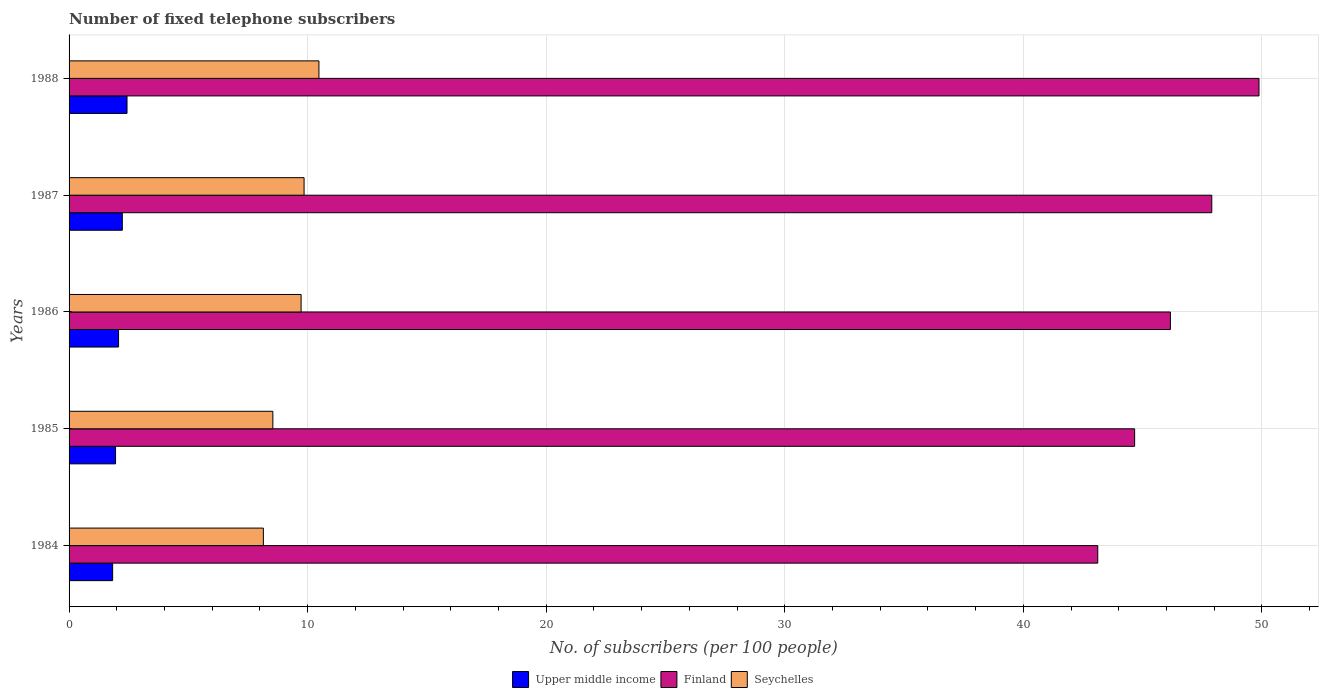Are the number of bars per tick equal to the number of legend labels?
Offer a very short reply. Yes. How many bars are there on the 2nd tick from the top?
Give a very brief answer. 3. In how many cases, is the number of bars for a given year not equal to the number of legend labels?
Provide a short and direct response. 0. What is the number of fixed telephone subscribers in Finland in 1987?
Offer a very short reply. 47.9. Across all years, what is the maximum number of fixed telephone subscribers in Finland?
Offer a terse response. 49.88. Across all years, what is the minimum number of fixed telephone subscribers in Seychelles?
Make the answer very short. 8.14. In which year was the number of fixed telephone subscribers in Upper middle income maximum?
Ensure brevity in your answer.  1988. In which year was the number of fixed telephone subscribers in Finland minimum?
Your response must be concise. 1984. What is the total number of fixed telephone subscribers in Upper middle income in the graph?
Make the answer very short. 10.51. What is the difference between the number of fixed telephone subscribers in Finland in 1985 and that in 1988?
Offer a very short reply. -5.21. What is the difference between the number of fixed telephone subscribers in Upper middle income in 1988 and the number of fixed telephone subscribers in Seychelles in 1986?
Offer a terse response. -7.3. What is the average number of fixed telephone subscribers in Upper middle income per year?
Offer a very short reply. 2.1. In the year 1988, what is the difference between the number of fixed telephone subscribers in Seychelles and number of fixed telephone subscribers in Upper middle income?
Ensure brevity in your answer.  8.05. What is the ratio of the number of fixed telephone subscribers in Upper middle income in 1986 to that in 1987?
Offer a terse response. 0.93. What is the difference between the highest and the second highest number of fixed telephone subscribers in Seychelles?
Provide a succinct answer. 0.62. What is the difference between the highest and the lowest number of fixed telephone subscribers in Seychelles?
Your answer should be very brief. 2.33. In how many years, is the number of fixed telephone subscribers in Seychelles greater than the average number of fixed telephone subscribers in Seychelles taken over all years?
Your answer should be very brief. 3. What does the 2nd bar from the top in 1984 represents?
Offer a terse response. Finland. What does the 2nd bar from the bottom in 1988 represents?
Provide a succinct answer. Finland. Is it the case that in every year, the sum of the number of fixed telephone subscribers in Seychelles and number of fixed telephone subscribers in Finland is greater than the number of fixed telephone subscribers in Upper middle income?
Provide a succinct answer. Yes. How many bars are there?
Ensure brevity in your answer.  15. Are all the bars in the graph horizontal?
Offer a terse response. Yes. How many years are there in the graph?
Your response must be concise. 5. Are the values on the major ticks of X-axis written in scientific E-notation?
Provide a short and direct response. No. Does the graph contain any zero values?
Offer a very short reply. No. Does the graph contain grids?
Your response must be concise. Yes. How many legend labels are there?
Ensure brevity in your answer.  3. How are the legend labels stacked?
Offer a terse response. Horizontal. What is the title of the graph?
Provide a short and direct response. Number of fixed telephone subscribers. Does "Latin America(developing only)" appear as one of the legend labels in the graph?
Provide a succinct answer. No. What is the label or title of the X-axis?
Make the answer very short. No. of subscribers (per 100 people). What is the label or title of the Y-axis?
Your answer should be very brief. Years. What is the No. of subscribers (per 100 people) in Upper middle income in 1984?
Ensure brevity in your answer.  1.83. What is the No. of subscribers (per 100 people) of Finland in 1984?
Offer a terse response. 43.12. What is the No. of subscribers (per 100 people) of Seychelles in 1984?
Give a very brief answer. 8.14. What is the No. of subscribers (per 100 people) in Upper middle income in 1985?
Keep it short and to the point. 1.95. What is the No. of subscribers (per 100 people) in Finland in 1985?
Provide a short and direct response. 44.67. What is the No. of subscribers (per 100 people) of Seychelles in 1985?
Give a very brief answer. 8.54. What is the No. of subscribers (per 100 people) of Upper middle income in 1986?
Your answer should be compact. 2.07. What is the No. of subscribers (per 100 people) in Finland in 1986?
Your answer should be compact. 46.17. What is the No. of subscribers (per 100 people) of Seychelles in 1986?
Provide a succinct answer. 9.73. What is the No. of subscribers (per 100 people) in Upper middle income in 1987?
Provide a short and direct response. 2.23. What is the No. of subscribers (per 100 people) of Finland in 1987?
Offer a terse response. 47.9. What is the No. of subscribers (per 100 people) of Seychelles in 1987?
Ensure brevity in your answer.  9.85. What is the No. of subscribers (per 100 people) in Upper middle income in 1988?
Your response must be concise. 2.43. What is the No. of subscribers (per 100 people) in Finland in 1988?
Offer a terse response. 49.88. What is the No. of subscribers (per 100 people) in Seychelles in 1988?
Make the answer very short. 10.47. Across all years, what is the maximum No. of subscribers (per 100 people) in Upper middle income?
Your answer should be very brief. 2.43. Across all years, what is the maximum No. of subscribers (per 100 people) in Finland?
Offer a terse response. 49.88. Across all years, what is the maximum No. of subscribers (per 100 people) of Seychelles?
Your answer should be very brief. 10.47. Across all years, what is the minimum No. of subscribers (per 100 people) of Upper middle income?
Your answer should be compact. 1.83. Across all years, what is the minimum No. of subscribers (per 100 people) in Finland?
Offer a terse response. 43.12. Across all years, what is the minimum No. of subscribers (per 100 people) in Seychelles?
Your response must be concise. 8.14. What is the total No. of subscribers (per 100 people) of Upper middle income in the graph?
Offer a terse response. 10.51. What is the total No. of subscribers (per 100 people) in Finland in the graph?
Provide a succinct answer. 231.74. What is the total No. of subscribers (per 100 people) in Seychelles in the graph?
Offer a very short reply. 46.74. What is the difference between the No. of subscribers (per 100 people) of Upper middle income in 1984 and that in 1985?
Give a very brief answer. -0.12. What is the difference between the No. of subscribers (per 100 people) in Finland in 1984 and that in 1985?
Provide a short and direct response. -1.55. What is the difference between the No. of subscribers (per 100 people) of Seychelles in 1984 and that in 1985?
Offer a very short reply. -0.4. What is the difference between the No. of subscribers (per 100 people) of Upper middle income in 1984 and that in 1986?
Ensure brevity in your answer.  -0.25. What is the difference between the No. of subscribers (per 100 people) in Finland in 1984 and that in 1986?
Make the answer very short. -3.05. What is the difference between the No. of subscribers (per 100 people) in Seychelles in 1984 and that in 1986?
Offer a very short reply. -1.58. What is the difference between the No. of subscribers (per 100 people) in Upper middle income in 1984 and that in 1987?
Your response must be concise. -0.41. What is the difference between the No. of subscribers (per 100 people) of Finland in 1984 and that in 1987?
Your answer should be compact. -4.78. What is the difference between the No. of subscribers (per 100 people) in Seychelles in 1984 and that in 1987?
Provide a succinct answer. -1.71. What is the difference between the No. of subscribers (per 100 people) in Upper middle income in 1984 and that in 1988?
Provide a short and direct response. -0.6. What is the difference between the No. of subscribers (per 100 people) in Finland in 1984 and that in 1988?
Your response must be concise. -6.76. What is the difference between the No. of subscribers (per 100 people) of Seychelles in 1984 and that in 1988?
Provide a short and direct response. -2.33. What is the difference between the No. of subscribers (per 100 people) of Upper middle income in 1985 and that in 1986?
Your answer should be compact. -0.13. What is the difference between the No. of subscribers (per 100 people) in Finland in 1985 and that in 1986?
Your response must be concise. -1.5. What is the difference between the No. of subscribers (per 100 people) of Seychelles in 1985 and that in 1986?
Keep it short and to the point. -1.18. What is the difference between the No. of subscribers (per 100 people) in Upper middle income in 1985 and that in 1987?
Your answer should be compact. -0.28. What is the difference between the No. of subscribers (per 100 people) in Finland in 1985 and that in 1987?
Ensure brevity in your answer.  -3.23. What is the difference between the No. of subscribers (per 100 people) in Seychelles in 1985 and that in 1987?
Offer a very short reply. -1.31. What is the difference between the No. of subscribers (per 100 people) in Upper middle income in 1985 and that in 1988?
Give a very brief answer. -0.48. What is the difference between the No. of subscribers (per 100 people) of Finland in 1985 and that in 1988?
Your response must be concise. -5.21. What is the difference between the No. of subscribers (per 100 people) in Seychelles in 1985 and that in 1988?
Make the answer very short. -1.93. What is the difference between the No. of subscribers (per 100 people) of Upper middle income in 1986 and that in 1987?
Make the answer very short. -0.16. What is the difference between the No. of subscribers (per 100 people) of Finland in 1986 and that in 1987?
Your response must be concise. -1.73. What is the difference between the No. of subscribers (per 100 people) in Seychelles in 1986 and that in 1987?
Ensure brevity in your answer.  -0.12. What is the difference between the No. of subscribers (per 100 people) of Upper middle income in 1986 and that in 1988?
Provide a succinct answer. -0.35. What is the difference between the No. of subscribers (per 100 people) of Finland in 1986 and that in 1988?
Keep it short and to the point. -3.71. What is the difference between the No. of subscribers (per 100 people) of Seychelles in 1986 and that in 1988?
Provide a short and direct response. -0.75. What is the difference between the No. of subscribers (per 100 people) of Upper middle income in 1987 and that in 1988?
Make the answer very short. -0.2. What is the difference between the No. of subscribers (per 100 people) of Finland in 1987 and that in 1988?
Your response must be concise. -1.98. What is the difference between the No. of subscribers (per 100 people) of Seychelles in 1987 and that in 1988?
Keep it short and to the point. -0.62. What is the difference between the No. of subscribers (per 100 people) in Upper middle income in 1984 and the No. of subscribers (per 100 people) in Finland in 1985?
Your answer should be very brief. -42.84. What is the difference between the No. of subscribers (per 100 people) in Upper middle income in 1984 and the No. of subscribers (per 100 people) in Seychelles in 1985?
Keep it short and to the point. -6.72. What is the difference between the No. of subscribers (per 100 people) in Finland in 1984 and the No. of subscribers (per 100 people) in Seychelles in 1985?
Keep it short and to the point. 34.58. What is the difference between the No. of subscribers (per 100 people) in Upper middle income in 1984 and the No. of subscribers (per 100 people) in Finland in 1986?
Your answer should be very brief. -44.34. What is the difference between the No. of subscribers (per 100 people) in Upper middle income in 1984 and the No. of subscribers (per 100 people) in Seychelles in 1986?
Ensure brevity in your answer.  -7.9. What is the difference between the No. of subscribers (per 100 people) in Finland in 1984 and the No. of subscribers (per 100 people) in Seychelles in 1986?
Keep it short and to the point. 33.4. What is the difference between the No. of subscribers (per 100 people) in Upper middle income in 1984 and the No. of subscribers (per 100 people) in Finland in 1987?
Ensure brevity in your answer.  -46.07. What is the difference between the No. of subscribers (per 100 people) of Upper middle income in 1984 and the No. of subscribers (per 100 people) of Seychelles in 1987?
Make the answer very short. -8.02. What is the difference between the No. of subscribers (per 100 people) of Finland in 1984 and the No. of subscribers (per 100 people) of Seychelles in 1987?
Make the answer very short. 33.27. What is the difference between the No. of subscribers (per 100 people) in Upper middle income in 1984 and the No. of subscribers (per 100 people) in Finland in 1988?
Keep it short and to the point. -48.05. What is the difference between the No. of subscribers (per 100 people) of Upper middle income in 1984 and the No. of subscribers (per 100 people) of Seychelles in 1988?
Provide a succinct answer. -8.65. What is the difference between the No. of subscribers (per 100 people) in Finland in 1984 and the No. of subscribers (per 100 people) in Seychelles in 1988?
Provide a short and direct response. 32.65. What is the difference between the No. of subscribers (per 100 people) of Upper middle income in 1985 and the No. of subscribers (per 100 people) of Finland in 1986?
Make the answer very short. -44.22. What is the difference between the No. of subscribers (per 100 people) in Upper middle income in 1985 and the No. of subscribers (per 100 people) in Seychelles in 1986?
Offer a very short reply. -7.78. What is the difference between the No. of subscribers (per 100 people) of Finland in 1985 and the No. of subscribers (per 100 people) of Seychelles in 1986?
Provide a short and direct response. 34.94. What is the difference between the No. of subscribers (per 100 people) of Upper middle income in 1985 and the No. of subscribers (per 100 people) of Finland in 1987?
Your answer should be very brief. -45.95. What is the difference between the No. of subscribers (per 100 people) of Upper middle income in 1985 and the No. of subscribers (per 100 people) of Seychelles in 1987?
Make the answer very short. -7.9. What is the difference between the No. of subscribers (per 100 people) of Finland in 1985 and the No. of subscribers (per 100 people) of Seychelles in 1987?
Give a very brief answer. 34.82. What is the difference between the No. of subscribers (per 100 people) in Upper middle income in 1985 and the No. of subscribers (per 100 people) in Finland in 1988?
Make the answer very short. -47.93. What is the difference between the No. of subscribers (per 100 people) in Upper middle income in 1985 and the No. of subscribers (per 100 people) in Seychelles in 1988?
Keep it short and to the point. -8.53. What is the difference between the No. of subscribers (per 100 people) in Finland in 1985 and the No. of subscribers (per 100 people) in Seychelles in 1988?
Ensure brevity in your answer.  34.19. What is the difference between the No. of subscribers (per 100 people) in Upper middle income in 1986 and the No. of subscribers (per 100 people) in Finland in 1987?
Ensure brevity in your answer.  -45.83. What is the difference between the No. of subscribers (per 100 people) in Upper middle income in 1986 and the No. of subscribers (per 100 people) in Seychelles in 1987?
Your answer should be very brief. -7.78. What is the difference between the No. of subscribers (per 100 people) of Finland in 1986 and the No. of subscribers (per 100 people) of Seychelles in 1987?
Ensure brevity in your answer.  36.32. What is the difference between the No. of subscribers (per 100 people) in Upper middle income in 1986 and the No. of subscribers (per 100 people) in Finland in 1988?
Your answer should be compact. -47.81. What is the difference between the No. of subscribers (per 100 people) of Upper middle income in 1986 and the No. of subscribers (per 100 people) of Seychelles in 1988?
Your answer should be very brief. -8.4. What is the difference between the No. of subscribers (per 100 people) in Finland in 1986 and the No. of subscribers (per 100 people) in Seychelles in 1988?
Give a very brief answer. 35.69. What is the difference between the No. of subscribers (per 100 people) of Upper middle income in 1987 and the No. of subscribers (per 100 people) of Finland in 1988?
Ensure brevity in your answer.  -47.65. What is the difference between the No. of subscribers (per 100 people) of Upper middle income in 1987 and the No. of subscribers (per 100 people) of Seychelles in 1988?
Offer a terse response. -8.24. What is the difference between the No. of subscribers (per 100 people) of Finland in 1987 and the No. of subscribers (per 100 people) of Seychelles in 1988?
Provide a succinct answer. 37.43. What is the average No. of subscribers (per 100 people) of Upper middle income per year?
Ensure brevity in your answer.  2.1. What is the average No. of subscribers (per 100 people) of Finland per year?
Ensure brevity in your answer.  46.35. What is the average No. of subscribers (per 100 people) of Seychelles per year?
Your response must be concise. 9.35. In the year 1984, what is the difference between the No. of subscribers (per 100 people) of Upper middle income and No. of subscribers (per 100 people) of Finland?
Make the answer very short. -41.3. In the year 1984, what is the difference between the No. of subscribers (per 100 people) in Upper middle income and No. of subscribers (per 100 people) in Seychelles?
Keep it short and to the point. -6.32. In the year 1984, what is the difference between the No. of subscribers (per 100 people) in Finland and No. of subscribers (per 100 people) in Seychelles?
Make the answer very short. 34.98. In the year 1985, what is the difference between the No. of subscribers (per 100 people) in Upper middle income and No. of subscribers (per 100 people) in Finland?
Provide a succinct answer. -42.72. In the year 1985, what is the difference between the No. of subscribers (per 100 people) of Upper middle income and No. of subscribers (per 100 people) of Seychelles?
Keep it short and to the point. -6.59. In the year 1985, what is the difference between the No. of subscribers (per 100 people) in Finland and No. of subscribers (per 100 people) in Seychelles?
Your answer should be very brief. 36.12. In the year 1986, what is the difference between the No. of subscribers (per 100 people) of Upper middle income and No. of subscribers (per 100 people) of Finland?
Provide a succinct answer. -44.09. In the year 1986, what is the difference between the No. of subscribers (per 100 people) in Upper middle income and No. of subscribers (per 100 people) in Seychelles?
Provide a short and direct response. -7.65. In the year 1986, what is the difference between the No. of subscribers (per 100 people) of Finland and No. of subscribers (per 100 people) of Seychelles?
Give a very brief answer. 36.44. In the year 1987, what is the difference between the No. of subscribers (per 100 people) of Upper middle income and No. of subscribers (per 100 people) of Finland?
Make the answer very short. -45.67. In the year 1987, what is the difference between the No. of subscribers (per 100 people) in Upper middle income and No. of subscribers (per 100 people) in Seychelles?
Keep it short and to the point. -7.62. In the year 1987, what is the difference between the No. of subscribers (per 100 people) of Finland and No. of subscribers (per 100 people) of Seychelles?
Offer a terse response. 38.05. In the year 1988, what is the difference between the No. of subscribers (per 100 people) of Upper middle income and No. of subscribers (per 100 people) of Finland?
Your response must be concise. -47.45. In the year 1988, what is the difference between the No. of subscribers (per 100 people) in Upper middle income and No. of subscribers (per 100 people) in Seychelles?
Offer a terse response. -8.05. In the year 1988, what is the difference between the No. of subscribers (per 100 people) in Finland and No. of subscribers (per 100 people) in Seychelles?
Provide a short and direct response. 39.41. What is the ratio of the No. of subscribers (per 100 people) in Upper middle income in 1984 to that in 1985?
Your response must be concise. 0.94. What is the ratio of the No. of subscribers (per 100 people) of Finland in 1984 to that in 1985?
Provide a short and direct response. 0.97. What is the ratio of the No. of subscribers (per 100 people) in Seychelles in 1984 to that in 1985?
Give a very brief answer. 0.95. What is the ratio of the No. of subscribers (per 100 people) in Upper middle income in 1984 to that in 1986?
Your answer should be very brief. 0.88. What is the ratio of the No. of subscribers (per 100 people) of Finland in 1984 to that in 1986?
Offer a terse response. 0.93. What is the ratio of the No. of subscribers (per 100 people) in Seychelles in 1984 to that in 1986?
Provide a short and direct response. 0.84. What is the ratio of the No. of subscribers (per 100 people) of Upper middle income in 1984 to that in 1987?
Provide a succinct answer. 0.82. What is the ratio of the No. of subscribers (per 100 people) of Finland in 1984 to that in 1987?
Keep it short and to the point. 0.9. What is the ratio of the No. of subscribers (per 100 people) of Seychelles in 1984 to that in 1987?
Give a very brief answer. 0.83. What is the ratio of the No. of subscribers (per 100 people) in Upper middle income in 1984 to that in 1988?
Keep it short and to the point. 0.75. What is the ratio of the No. of subscribers (per 100 people) in Finland in 1984 to that in 1988?
Your answer should be very brief. 0.86. What is the ratio of the No. of subscribers (per 100 people) of Seychelles in 1984 to that in 1988?
Keep it short and to the point. 0.78. What is the ratio of the No. of subscribers (per 100 people) of Upper middle income in 1985 to that in 1986?
Keep it short and to the point. 0.94. What is the ratio of the No. of subscribers (per 100 people) of Finland in 1985 to that in 1986?
Provide a succinct answer. 0.97. What is the ratio of the No. of subscribers (per 100 people) of Seychelles in 1985 to that in 1986?
Keep it short and to the point. 0.88. What is the ratio of the No. of subscribers (per 100 people) of Upper middle income in 1985 to that in 1987?
Provide a succinct answer. 0.87. What is the ratio of the No. of subscribers (per 100 people) in Finland in 1985 to that in 1987?
Provide a short and direct response. 0.93. What is the ratio of the No. of subscribers (per 100 people) of Seychelles in 1985 to that in 1987?
Give a very brief answer. 0.87. What is the ratio of the No. of subscribers (per 100 people) in Upper middle income in 1985 to that in 1988?
Your answer should be very brief. 0.8. What is the ratio of the No. of subscribers (per 100 people) of Finland in 1985 to that in 1988?
Your response must be concise. 0.9. What is the ratio of the No. of subscribers (per 100 people) in Seychelles in 1985 to that in 1988?
Make the answer very short. 0.82. What is the ratio of the No. of subscribers (per 100 people) of Upper middle income in 1986 to that in 1987?
Your response must be concise. 0.93. What is the ratio of the No. of subscribers (per 100 people) in Finland in 1986 to that in 1987?
Offer a terse response. 0.96. What is the ratio of the No. of subscribers (per 100 people) of Seychelles in 1986 to that in 1987?
Your answer should be very brief. 0.99. What is the ratio of the No. of subscribers (per 100 people) in Upper middle income in 1986 to that in 1988?
Keep it short and to the point. 0.85. What is the ratio of the No. of subscribers (per 100 people) of Finland in 1986 to that in 1988?
Provide a short and direct response. 0.93. What is the ratio of the No. of subscribers (per 100 people) in Upper middle income in 1987 to that in 1988?
Provide a short and direct response. 0.92. What is the ratio of the No. of subscribers (per 100 people) in Finland in 1987 to that in 1988?
Provide a succinct answer. 0.96. What is the ratio of the No. of subscribers (per 100 people) in Seychelles in 1987 to that in 1988?
Make the answer very short. 0.94. What is the difference between the highest and the second highest No. of subscribers (per 100 people) in Upper middle income?
Give a very brief answer. 0.2. What is the difference between the highest and the second highest No. of subscribers (per 100 people) of Finland?
Provide a succinct answer. 1.98. What is the difference between the highest and the second highest No. of subscribers (per 100 people) in Seychelles?
Provide a short and direct response. 0.62. What is the difference between the highest and the lowest No. of subscribers (per 100 people) of Upper middle income?
Ensure brevity in your answer.  0.6. What is the difference between the highest and the lowest No. of subscribers (per 100 people) of Finland?
Ensure brevity in your answer.  6.76. What is the difference between the highest and the lowest No. of subscribers (per 100 people) of Seychelles?
Your answer should be very brief. 2.33. 